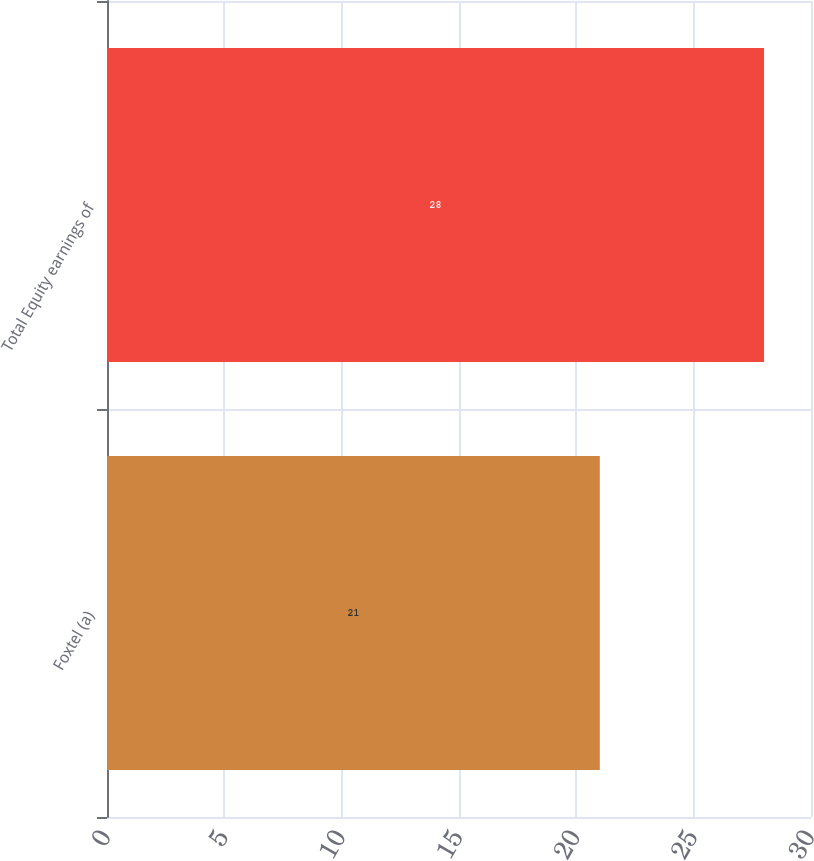<chart> <loc_0><loc_0><loc_500><loc_500><bar_chart><fcel>Foxtel (a)<fcel>Total Equity earnings of<nl><fcel>21<fcel>28<nl></chart> 